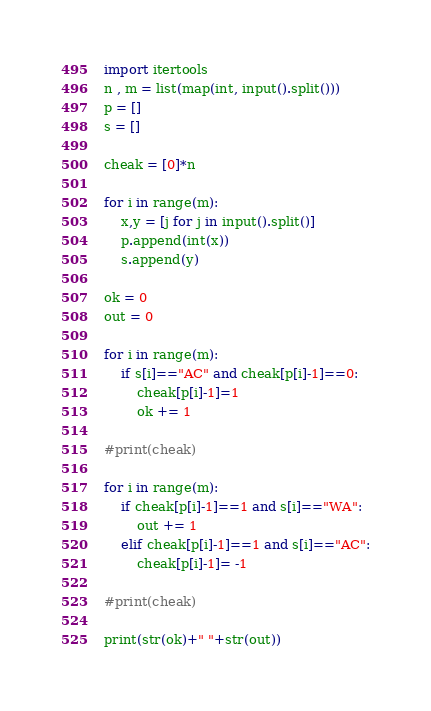Convert code to text. <code><loc_0><loc_0><loc_500><loc_500><_Python_>import itertools
n , m = list(map(int, input().split()))
p = []
s = []

cheak = [0]*n

for i in range(m):
    x,y = [j for j in input().split()]
    p.append(int(x))
    s.append(y)

ok = 0
out = 0

for i in range(m):
    if s[i]=="AC" and cheak[p[i]-1]==0:
        cheak[p[i]-1]=1
        ok += 1

#print(cheak)

for i in range(m):
    if cheak[p[i]-1]==1 and s[i]=="WA":
        out += 1
    elif cheak[p[i]-1]==1 and s[i]=="AC":
        cheak[p[i]-1]= -1

#print(cheak)      

print(str(ok)+" "+str(out))


</code> 